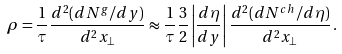<formula> <loc_0><loc_0><loc_500><loc_500>\rho = \frac { 1 } { \tau } \frac { d ^ { 2 } ( d N ^ { g } / d y ) } { d ^ { 2 } { x } _ { \perp } } \approx \frac { 1 } { \tau } \frac { 3 } { 2 } \left | \frac { d \eta } { d y } \right | \frac { d ^ { 2 } ( d N ^ { c h } / d \eta ) } { d ^ { 2 } { x } _ { \perp } } \, .</formula> 